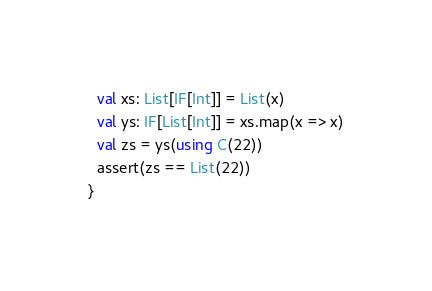<code> <loc_0><loc_0><loc_500><loc_500><_Scala_>  val xs: List[IF[Int]] = List(x)
  val ys: IF[List[Int]] = xs.map(x => x)
  val zs = ys(using C(22))
  assert(zs == List(22))
}
</code> 